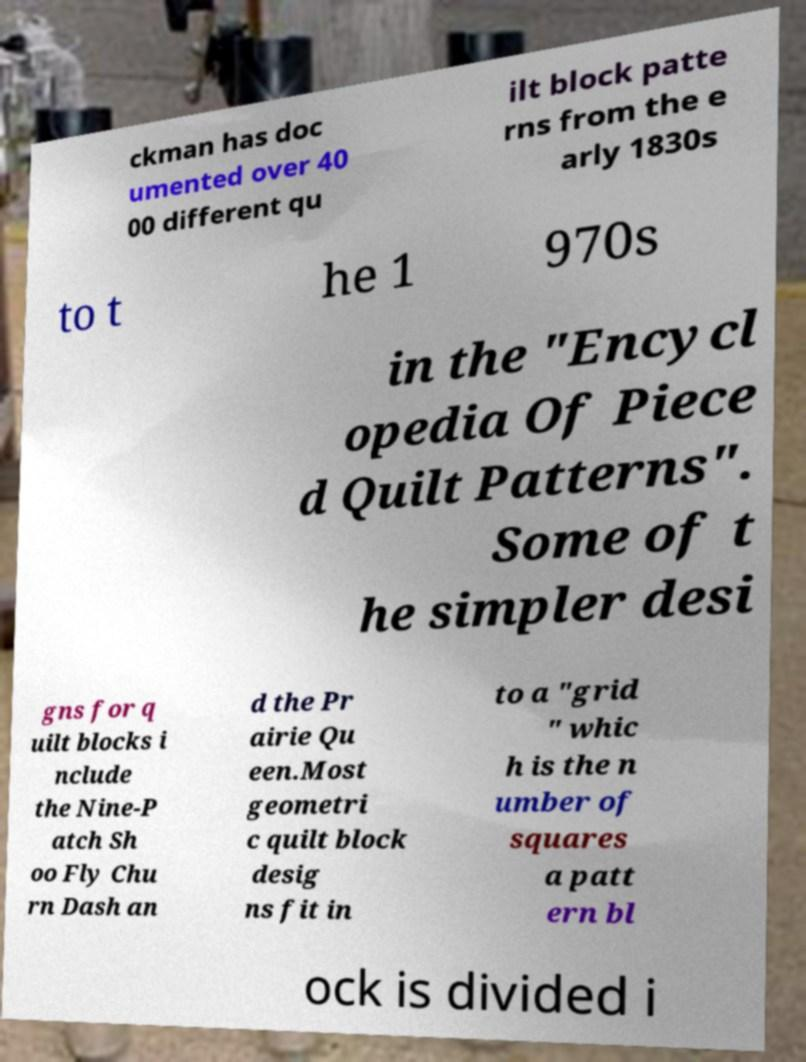Can you accurately transcribe the text from the provided image for me? ckman has doc umented over 40 00 different qu ilt block patte rns from the e arly 1830s to t he 1 970s in the "Encycl opedia Of Piece d Quilt Patterns". Some of t he simpler desi gns for q uilt blocks i nclude the Nine-P atch Sh oo Fly Chu rn Dash an d the Pr airie Qu een.Most geometri c quilt block desig ns fit in to a "grid " whic h is the n umber of squares a patt ern bl ock is divided i 